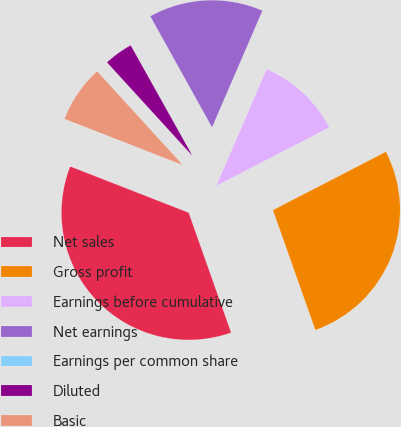<chart> <loc_0><loc_0><loc_500><loc_500><pie_chart><fcel>Net sales<fcel>Gross profit<fcel>Earnings before cumulative<fcel>Net earnings<fcel>Earnings per common share<fcel>Diluted<fcel>Basic<nl><fcel>36.34%<fcel>27.18%<fcel>10.93%<fcel>14.56%<fcel>0.04%<fcel>3.67%<fcel>7.3%<nl></chart> 